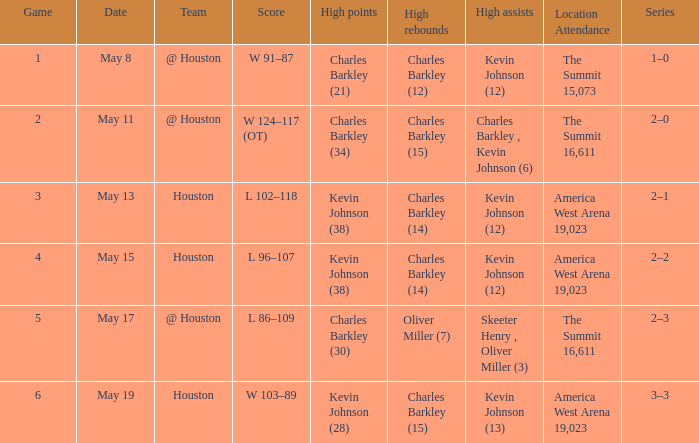In how many various games did oliver miller (7) perform the high rebounds? 1.0. 